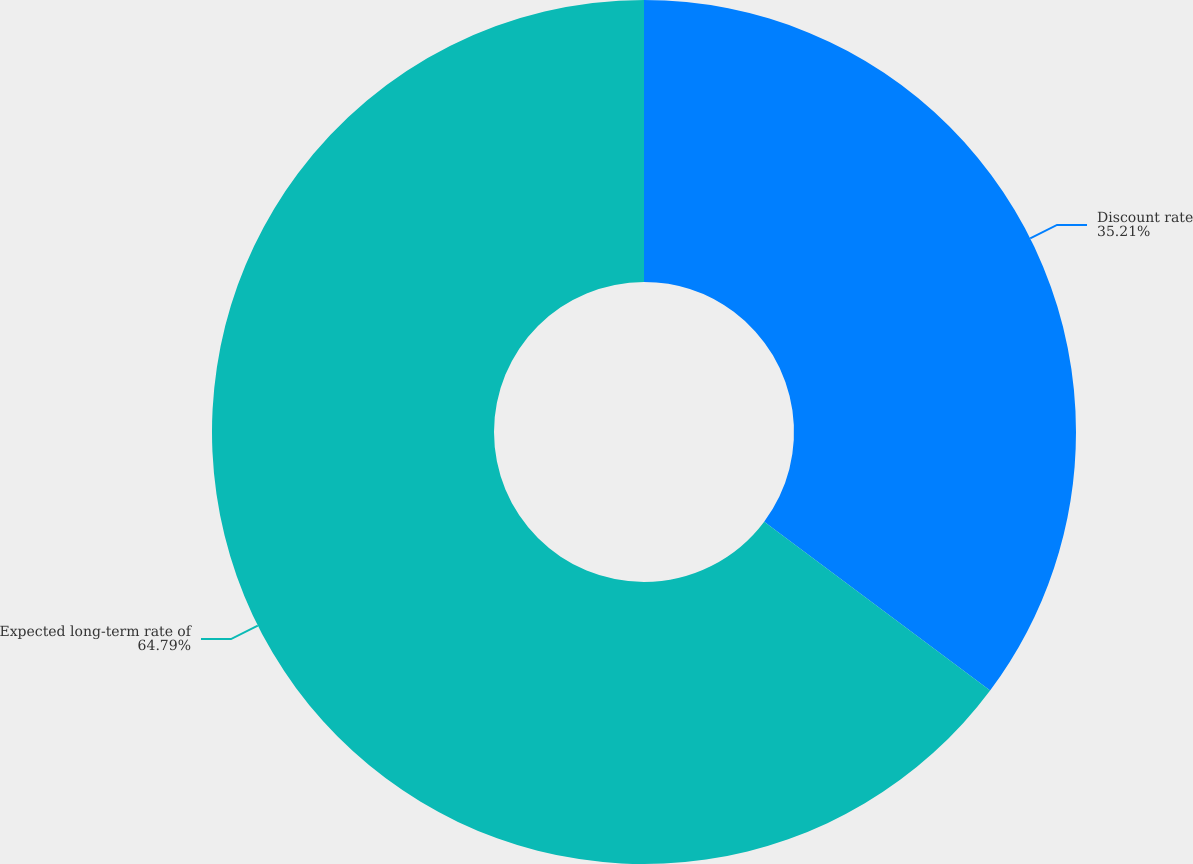<chart> <loc_0><loc_0><loc_500><loc_500><pie_chart><fcel>Discount rate<fcel>Expected long-term rate of<nl><fcel>35.21%<fcel>64.79%<nl></chart> 